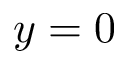<formula> <loc_0><loc_0><loc_500><loc_500>y = 0</formula> 